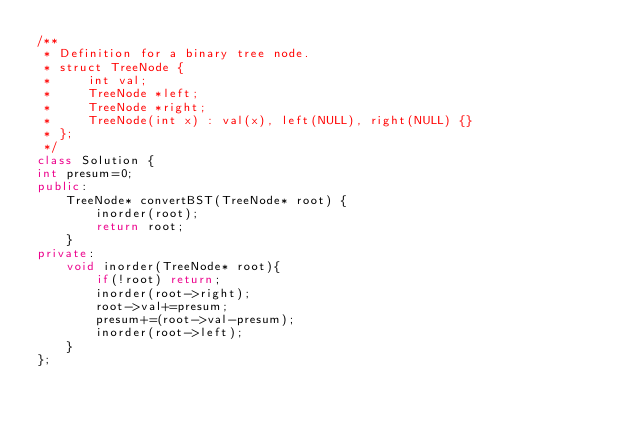Convert code to text. <code><loc_0><loc_0><loc_500><loc_500><_C++_>/**
 * Definition for a binary tree node.
 * struct TreeNode {
 *     int val;
 *     TreeNode *left;
 *     TreeNode *right;
 *     TreeNode(int x) : val(x), left(NULL), right(NULL) {}
 * };
 */
class Solution {
int presum=0;
public:
    TreeNode* convertBST(TreeNode* root) {
        inorder(root);
        return root;
    }
private:
    void inorder(TreeNode* root){
        if(!root) return;
        inorder(root->right);
        root->val+=presum;
        presum+=(root->val-presum);
        inorder(root->left);
    }
};
</code> 